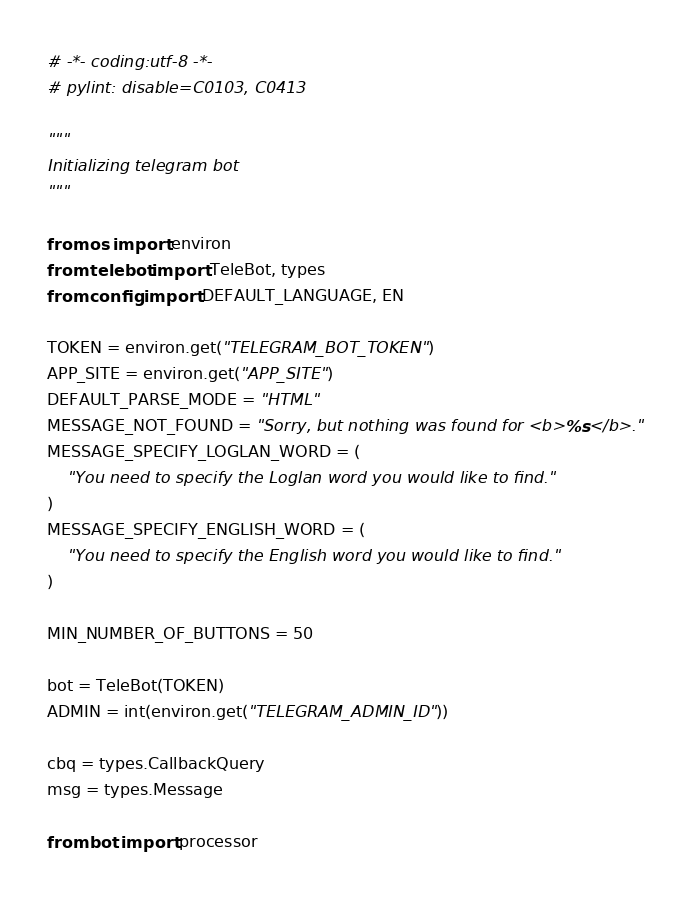<code> <loc_0><loc_0><loc_500><loc_500><_Python_># -*- coding:utf-8 -*-
# pylint: disable=C0103, C0413

"""
Initializing telegram bot
"""

from os import environ
from telebot import TeleBot, types
from config import DEFAULT_LANGUAGE, EN

TOKEN = environ.get("TELEGRAM_BOT_TOKEN")
APP_SITE = environ.get("APP_SITE")
DEFAULT_PARSE_MODE = "HTML"
MESSAGE_NOT_FOUND = "Sorry, but nothing was found for <b>%s</b>."
MESSAGE_SPECIFY_LOGLAN_WORD = (
    "You need to specify the Loglan word you would like to find."
)
MESSAGE_SPECIFY_ENGLISH_WORD = (
    "You need to specify the English word you would like to find."
)

MIN_NUMBER_OF_BUTTONS = 50

bot = TeleBot(TOKEN)
ADMIN = int(environ.get("TELEGRAM_ADMIN_ID"))

cbq = types.CallbackQuery
msg = types.Message

from bot import processor
</code> 